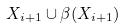<formula> <loc_0><loc_0><loc_500><loc_500>X _ { i + 1 } \cup \beta ( X _ { i + 1 } )</formula> 